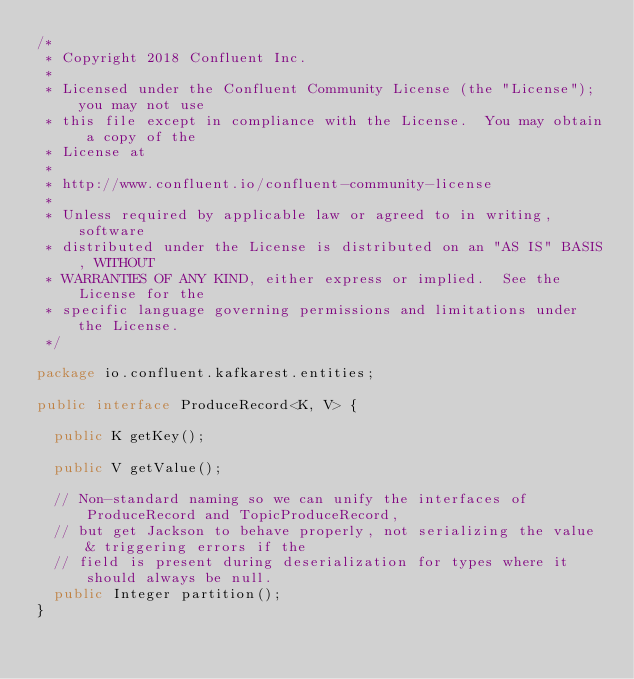Convert code to text. <code><loc_0><loc_0><loc_500><loc_500><_Java_>/*
 * Copyright 2018 Confluent Inc.
 *
 * Licensed under the Confluent Community License (the "License"); you may not use
 * this file except in compliance with the License.  You may obtain a copy of the
 * License at
 *
 * http://www.confluent.io/confluent-community-license
 *
 * Unless required by applicable law or agreed to in writing, software
 * distributed under the License is distributed on an "AS IS" BASIS, WITHOUT
 * WARRANTIES OF ANY KIND, either express or implied.  See the License for the
 * specific language governing permissions and limitations under the License.
 */

package io.confluent.kafkarest.entities;

public interface ProduceRecord<K, V> {

  public K getKey();

  public V getValue();

  // Non-standard naming so we can unify the interfaces of ProduceRecord and TopicProduceRecord,
  // but get Jackson to behave properly, not serializing the value & triggering errors if the
  // field is present during deserialization for types where it should always be null.
  public Integer partition();
}</code> 